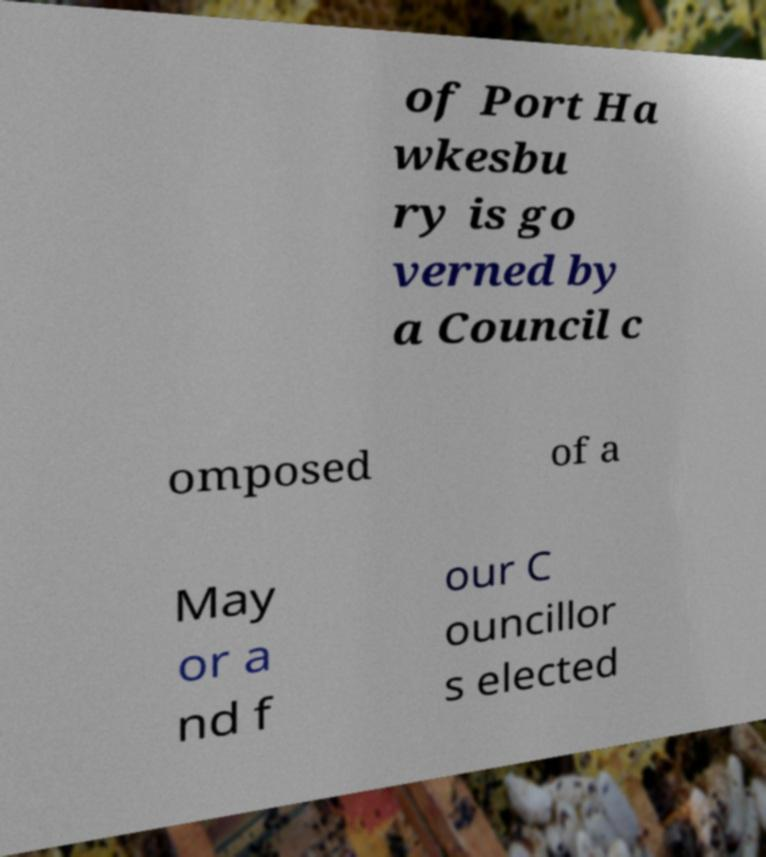Please identify and transcribe the text found in this image. of Port Ha wkesbu ry is go verned by a Council c omposed of a May or a nd f our C ouncillor s elected 